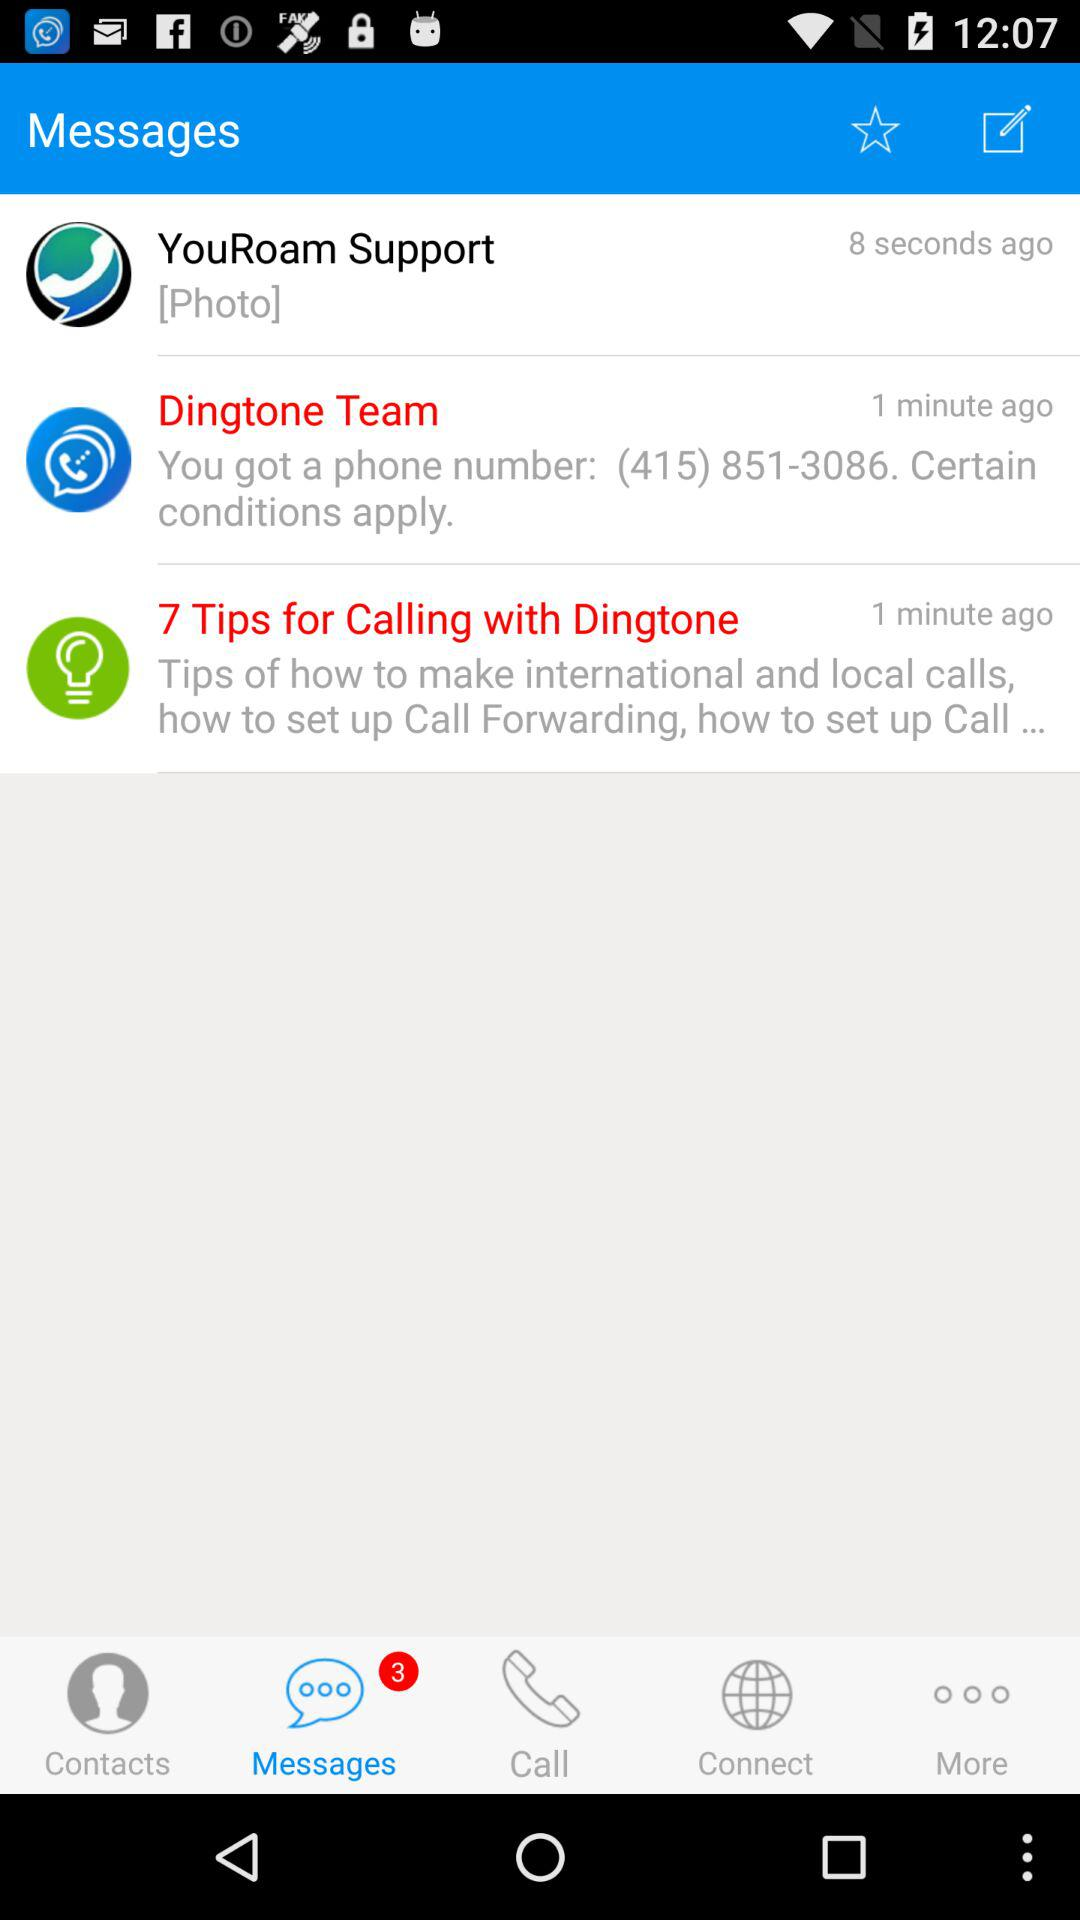How many messages are there in the inbox?
Answer the question using a single word or phrase. 3 